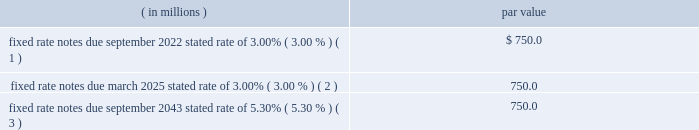Fund collateral , net of the distribution of interest earned to the clearing firms , as well as an increase in trading volumes and the reduction of restricted cash related to the cme clearing europe limited ( cmece ) guaranty the increase in 2016 when compared with 2015 was attributable to higher clearing and transaction fees and market data revenue .
Investing activities the increases in cash provided by investing activities from 2015 through 2017 were due to proceeds from the sale of bm&fbovespa shares as well as declines in purchases of property and equipment .
The increase in 2017 when compared with 2016 was also attributable to the sale of the remaining bolsa mexicana de valores , s.a.b .
De c.v .
Shares .
Financing activities the increases in cash used by financing activities from 2015 through 2017 were attributable to higher cash dividends declared in 2017 and 2016 .
The increase in 2016 was partially offset by proceeds from a finance lease obligation related to the sale leaseback of the datacenter in the first quarter of 2016 .
Debt instruments the table summarizes our debt outstanding as of december 31 , 2017: .
Fixed rate notes due september 2022 , stated rate of 3.00% ( 3.00 % ) ( 1 ) .
$ 750.0 fixed rate notes due march 2025 , stated rate of 3.00% ( 3.00 % ) ( 2 ) .
750.0 fixed rate notes due september 2043 , stated rate of 5.30% ( 5.30 % ) ( 3 ) .
750.0 ( 1 ) in august 2012 , we entered into a forward-starting interest rate swap agreement that modified the interest obligation associated with these notes so that the interest payable on the notes effectively became fixed at a rate of 3.32% ( 3.32 % ) .
( 2 ) in december 2014 , we entered into a forward-starting interest rate swap agreement that modified the interest obligation associated with these notes so that the interest payable on the notes effectively became fixed at a rate of 3.11% ( 3.11 % ) .
( 3 ) in august 2012 , we entered into a forward-starting interest rate swap agreement that modified the interest obligation associated with these notes so that the interest payable effectively became fixed at a rate of 4.73% ( 4.73 % ) .
We maintain a $ 2.3 billion multi-currency revolving senior credit facility with various financial institutions , which matures in november 2022 .
The proceeds from this facility can be used for general corporate purposes , which includes providing liquidity for our clearing house in certain circumstances at cme group 2019s discretion and , if necessary , for maturities of commercial paper .
As long as we are not in default under this facility , we have the option to increase it up to $ 3.0 billion with the consent of the agent and lenders providing the additional funds .
This facility is voluntarily pre-payable from time to time without premium or penalty .
Under this facility , we are required to remain in compliance with a consolidated net worth test , which is defined as our consolidated shareholders 2019 equity at september 30 , 2017 , giving effect to share repurchases made and special dividends paid during the term of the agreements ( and in no event greater than $ 2.0 billion in aggregate ) , multiplied by 0.65 .
We currently do not have any borrowings outstanding under this facility .
We maintain a 364-day multi-currency revolving secured credit facility with a consortium of domestic and international banks to be used in certain situations by cme clearing .
The facility provides for borrowings of up to $ 7.0 billion .
We may use the proceeds to provide temporary liquidity in the unlikely event of a clearing firm default , in the event of a liquidity constraint or default by a depositary ( custodian for our collateral ) , or in the event of a temporary disruption with the domestic payments system that would delay payment of settlement variation between us and our clearing firms .
Clearing firm guaranty fund contributions received in the form of .
What was the decrease in the interest payable between august 2012 and in december 2014? 
Rationale: its the difference bewteen the interest rates
Computations: (3.11 - 3.32)
Answer: -0.21. 